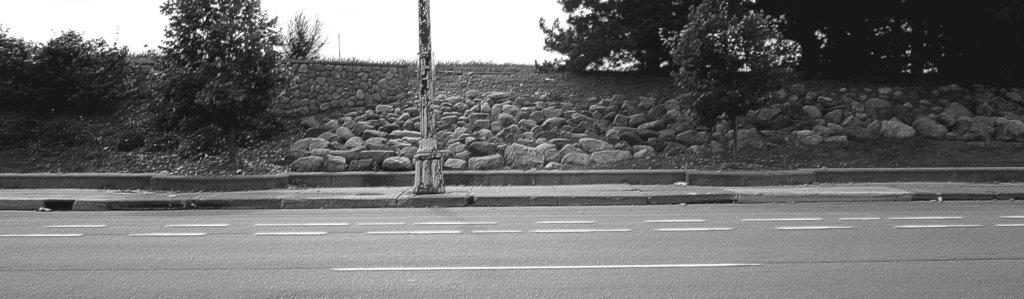What is the color scheme of the image? The image is black and white. What can be seen at the bottom of the image? There is a road at the bottom of the image. What is located in the middle of the image? There is a pole and trees in the middle of the image. What other objects can be seen in the middle of the image? Rocks are visible in the middle of the image. What is visible at the top of the image? The sky is present at the top of the image. How many pins are attached to the pole in the image? There are no pins present in the image; the pole is standing alone. What type of smoke can be seen coming from the trees in the image? There is no smoke visible in the image; the trees are not on fire or producing any smoke. 